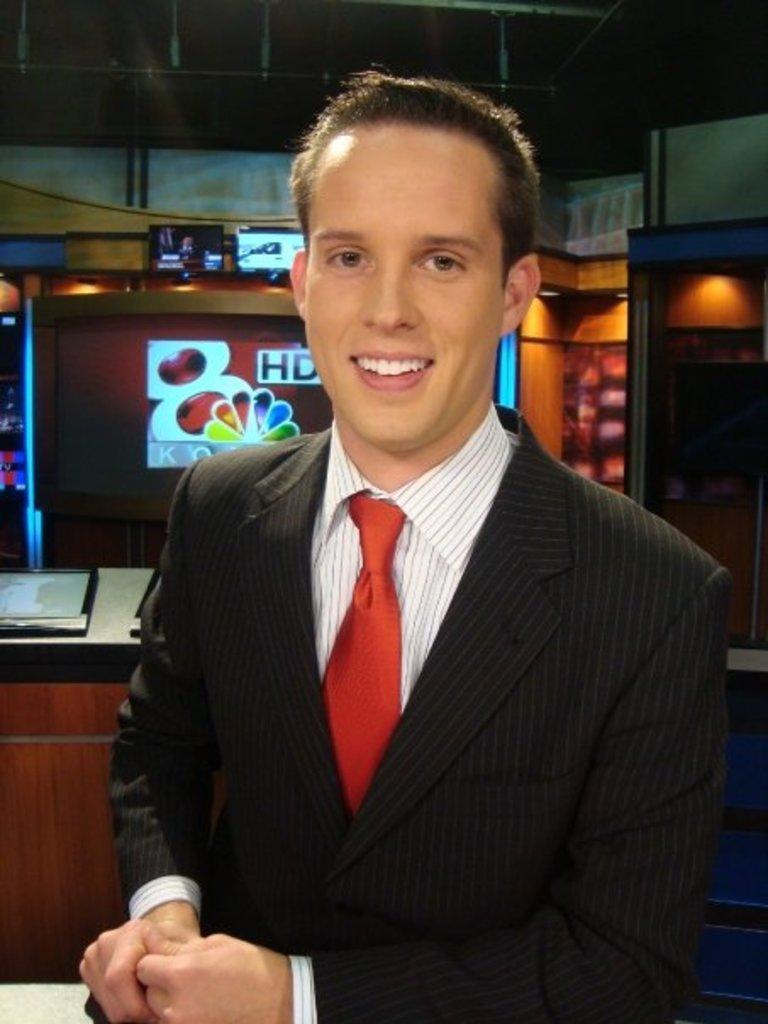In one or two sentences, can you explain what this image depicts? In this image there is a man, he is wearing white color shirt, black coat ,red tie, in the background there is a shop. 